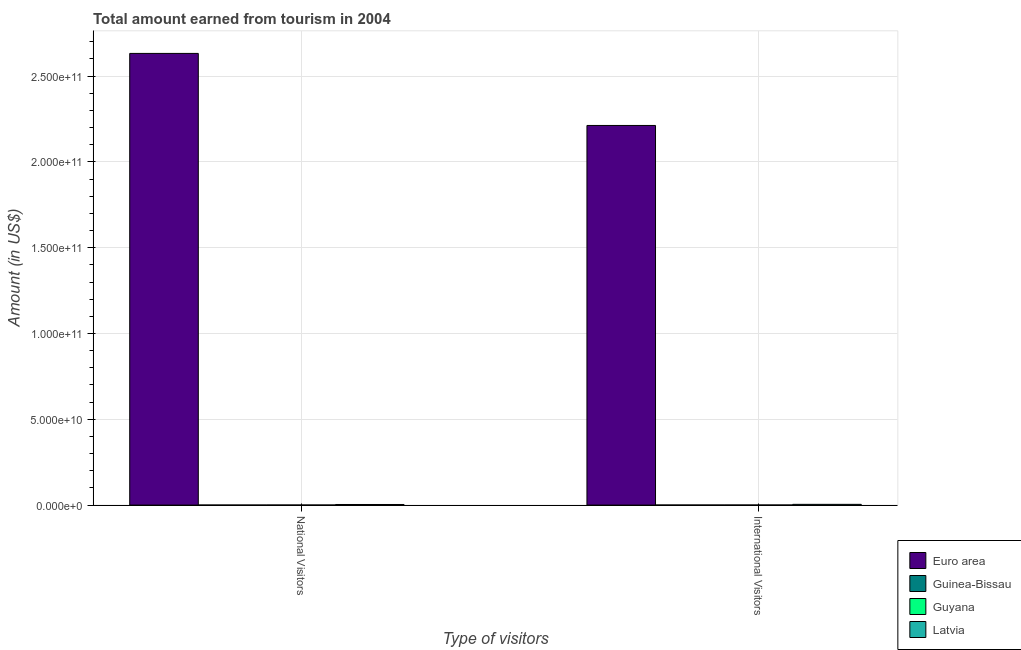How many groups of bars are there?
Your answer should be very brief. 2. How many bars are there on the 2nd tick from the left?
Your response must be concise. 4. How many bars are there on the 1st tick from the right?
Ensure brevity in your answer.  4. What is the label of the 1st group of bars from the left?
Ensure brevity in your answer.  National Visitors. What is the amount earned from national visitors in Euro area?
Provide a short and direct response. 2.63e+11. Across all countries, what is the maximum amount earned from international visitors?
Ensure brevity in your answer.  2.21e+11. Across all countries, what is the minimum amount earned from international visitors?
Provide a succinct answer. 2.23e+07. In which country was the amount earned from national visitors maximum?
Provide a short and direct response. Euro area. In which country was the amount earned from international visitors minimum?
Keep it short and to the point. Guinea-Bissau. What is the total amount earned from international visitors in the graph?
Provide a succinct answer. 2.22e+11. What is the difference between the amount earned from national visitors in Guinea-Bissau and that in Guyana?
Ensure brevity in your answer.  -2.48e+07. What is the difference between the amount earned from national visitors in Guyana and the amount earned from international visitors in Guinea-Bissau?
Offer a terse response. 4.70e+06. What is the average amount earned from national visitors per country?
Your answer should be very brief. 6.59e+1. What is the difference between the amount earned from international visitors and amount earned from national visitors in Guyana?
Make the answer very short. 3.00e+06. In how many countries, is the amount earned from international visitors greater than 70000000000 US$?
Provide a short and direct response. 1. What is the ratio of the amount earned from international visitors in Latvia to that in Guyana?
Your response must be concise. 14.27. Is the amount earned from national visitors in Latvia less than that in Guyana?
Provide a short and direct response. No. What does the 4th bar from the left in International Visitors represents?
Your answer should be very brief. Latvia. What does the 3rd bar from the right in International Visitors represents?
Offer a very short reply. Guinea-Bissau. How many bars are there?
Keep it short and to the point. 8. Are all the bars in the graph horizontal?
Give a very brief answer. No. Does the graph contain any zero values?
Provide a short and direct response. No. Does the graph contain grids?
Offer a very short reply. Yes. How are the legend labels stacked?
Provide a succinct answer. Vertical. What is the title of the graph?
Provide a short and direct response. Total amount earned from tourism in 2004. Does "St. Martin (French part)" appear as one of the legend labels in the graph?
Give a very brief answer. No. What is the label or title of the X-axis?
Ensure brevity in your answer.  Type of visitors. What is the Amount (in US$) of Euro area in National Visitors?
Keep it short and to the point. 2.63e+11. What is the Amount (in US$) of Guinea-Bissau in National Visitors?
Offer a terse response. 2.20e+06. What is the Amount (in US$) in Guyana in National Visitors?
Your answer should be very brief. 2.70e+07. What is the Amount (in US$) of Latvia in National Visitors?
Your response must be concise. 3.43e+08. What is the Amount (in US$) in Euro area in International Visitors?
Offer a terse response. 2.21e+11. What is the Amount (in US$) in Guinea-Bissau in International Visitors?
Give a very brief answer. 2.23e+07. What is the Amount (in US$) of Guyana in International Visitors?
Ensure brevity in your answer.  3.00e+07. What is the Amount (in US$) of Latvia in International Visitors?
Provide a succinct answer. 4.28e+08. Across all Type of visitors, what is the maximum Amount (in US$) in Euro area?
Your answer should be compact. 2.63e+11. Across all Type of visitors, what is the maximum Amount (in US$) of Guinea-Bissau?
Keep it short and to the point. 2.23e+07. Across all Type of visitors, what is the maximum Amount (in US$) of Guyana?
Offer a terse response. 3.00e+07. Across all Type of visitors, what is the maximum Amount (in US$) of Latvia?
Make the answer very short. 4.28e+08. Across all Type of visitors, what is the minimum Amount (in US$) of Euro area?
Provide a short and direct response. 2.21e+11. Across all Type of visitors, what is the minimum Amount (in US$) of Guinea-Bissau?
Offer a terse response. 2.20e+06. Across all Type of visitors, what is the minimum Amount (in US$) in Guyana?
Your answer should be very brief. 2.70e+07. Across all Type of visitors, what is the minimum Amount (in US$) of Latvia?
Keep it short and to the point. 3.43e+08. What is the total Amount (in US$) in Euro area in the graph?
Give a very brief answer. 4.84e+11. What is the total Amount (in US$) in Guinea-Bissau in the graph?
Make the answer very short. 2.45e+07. What is the total Amount (in US$) of Guyana in the graph?
Ensure brevity in your answer.  5.70e+07. What is the total Amount (in US$) in Latvia in the graph?
Keep it short and to the point. 7.71e+08. What is the difference between the Amount (in US$) in Euro area in National Visitors and that in International Visitors?
Your answer should be very brief. 4.20e+1. What is the difference between the Amount (in US$) in Guinea-Bissau in National Visitors and that in International Visitors?
Give a very brief answer. -2.01e+07. What is the difference between the Amount (in US$) of Guyana in National Visitors and that in International Visitors?
Ensure brevity in your answer.  -3.00e+06. What is the difference between the Amount (in US$) in Latvia in National Visitors and that in International Visitors?
Offer a terse response. -8.50e+07. What is the difference between the Amount (in US$) of Euro area in National Visitors and the Amount (in US$) of Guinea-Bissau in International Visitors?
Offer a very short reply. 2.63e+11. What is the difference between the Amount (in US$) of Euro area in National Visitors and the Amount (in US$) of Guyana in International Visitors?
Give a very brief answer. 2.63e+11. What is the difference between the Amount (in US$) of Euro area in National Visitors and the Amount (in US$) of Latvia in International Visitors?
Your response must be concise. 2.63e+11. What is the difference between the Amount (in US$) of Guinea-Bissau in National Visitors and the Amount (in US$) of Guyana in International Visitors?
Your answer should be very brief. -2.78e+07. What is the difference between the Amount (in US$) in Guinea-Bissau in National Visitors and the Amount (in US$) in Latvia in International Visitors?
Your answer should be compact. -4.26e+08. What is the difference between the Amount (in US$) of Guyana in National Visitors and the Amount (in US$) of Latvia in International Visitors?
Provide a short and direct response. -4.01e+08. What is the average Amount (in US$) in Euro area per Type of visitors?
Give a very brief answer. 2.42e+11. What is the average Amount (in US$) of Guinea-Bissau per Type of visitors?
Your answer should be very brief. 1.22e+07. What is the average Amount (in US$) in Guyana per Type of visitors?
Ensure brevity in your answer.  2.85e+07. What is the average Amount (in US$) of Latvia per Type of visitors?
Provide a short and direct response. 3.86e+08. What is the difference between the Amount (in US$) of Euro area and Amount (in US$) of Guinea-Bissau in National Visitors?
Your answer should be compact. 2.63e+11. What is the difference between the Amount (in US$) of Euro area and Amount (in US$) of Guyana in National Visitors?
Ensure brevity in your answer.  2.63e+11. What is the difference between the Amount (in US$) of Euro area and Amount (in US$) of Latvia in National Visitors?
Provide a succinct answer. 2.63e+11. What is the difference between the Amount (in US$) in Guinea-Bissau and Amount (in US$) in Guyana in National Visitors?
Provide a short and direct response. -2.48e+07. What is the difference between the Amount (in US$) in Guinea-Bissau and Amount (in US$) in Latvia in National Visitors?
Offer a very short reply. -3.41e+08. What is the difference between the Amount (in US$) of Guyana and Amount (in US$) of Latvia in National Visitors?
Provide a succinct answer. -3.16e+08. What is the difference between the Amount (in US$) of Euro area and Amount (in US$) of Guinea-Bissau in International Visitors?
Offer a very short reply. 2.21e+11. What is the difference between the Amount (in US$) in Euro area and Amount (in US$) in Guyana in International Visitors?
Make the answer very short. 2.21e+11. What is the difference between the Amount (in US$) of Euro area and Amount (in US$) of Latvia in International Visitors?
Keep it short and to the point. 2.21e+11. What is the difference between the Amount (in US$) in Guinea-Bissau and Amount (in US$) in Guyana in International Visitors?
Offer a very short reply. -7.70e+06. What is the difference between the Amount (in US$) in Guinea-Bissau and Amount (in US$) in Latvia in International Visitors?
Your response must be concise. -4.06e+08. What is the difference between the Amount (in US$) of Guyana and Amount (in US$) of Latvia in International Visitors?
Give a very brief answer. -3.98e+08. What is the ratio of the Amount (in US$) of Euro area in National Visitors to that in International Visitors?
Your answer should be very brief. 1.19. What is the ratio of the Amount (in US$) of Guinea-Bissau in National Visitors to that in International Visitors?
Your answer should be very brief. 0.1. What is the ratio of the Amount (in US$) of Guyana in National Visitors to that in International Visitors?
Offer a terse response. 0.9. What is the ratio of the Amount (in US$) in Latvia in National Visitors to that in International Visitors?
Keep it short and to the point. 0.8. What is the difference between the highest and the second highest Amount (in US$) of Euro area?
Ensure brevity in your answer.  4.20e+1. What is the difference between the highest and the second highest Amount (in US$) in Guinea-Bissau?
Ensure brevity in your answer.  2.01e+07. What is the difference between the highest and the second highest Amount (in US$) of Latvia?
Provide a short and direct response. 8.50e+07. What is the difference between the highest and the lowest Amount (in US$) in Euro area?
Provide a succinct answer. 4.20e+1. What is the difference between the highest and the lowest Amount (in US$) of Guinea-Bissau?
Make the answer very short. 2.01e+07. What is the difference between the highest and the lowest Amount (in US$) of Latvia?
Provide a succinct answer. 8.50e+07. 